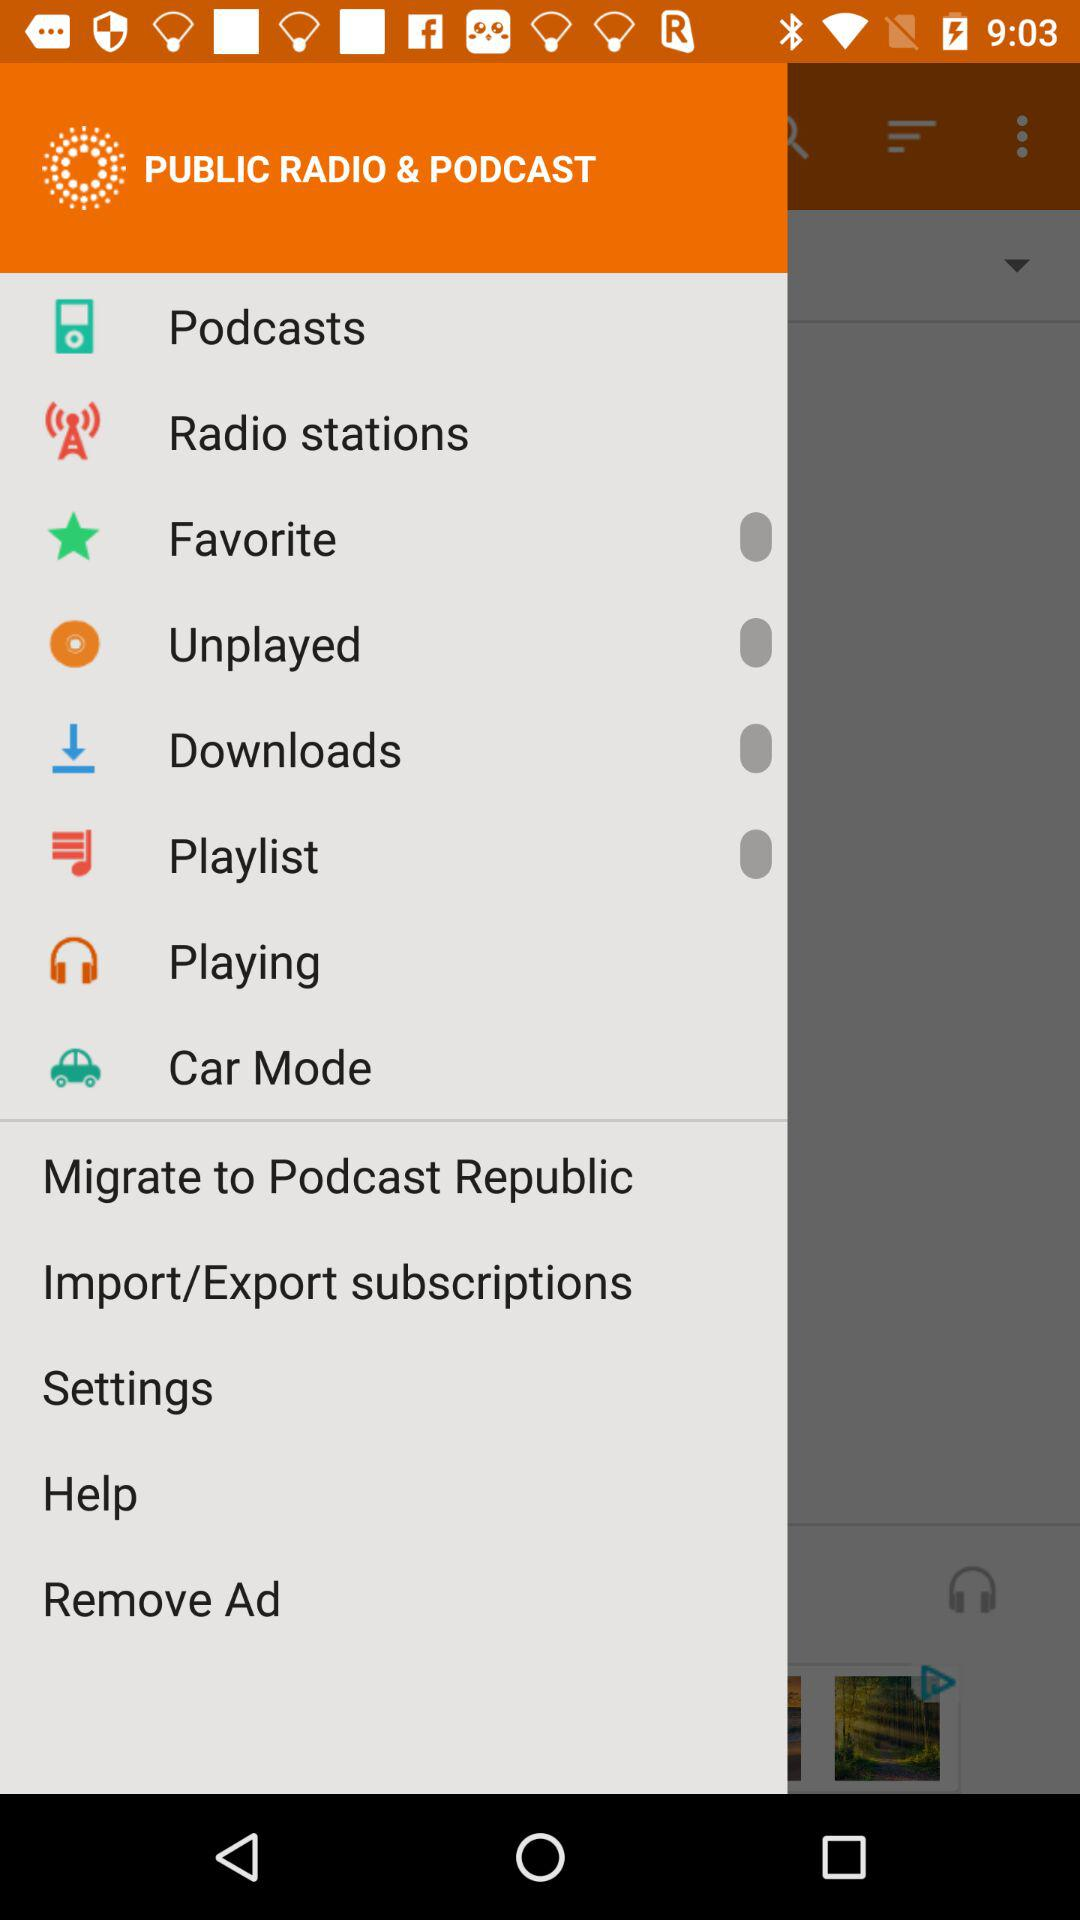What is the name of the application? The name of the application is "PUBLIC RADIO & PODCAST". 